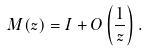<formula> <loc_0><loc_0><loc_500><loc_500>M ( z ) = I + O \left ( \frac { 1 } { z } \right ) .</formula> 